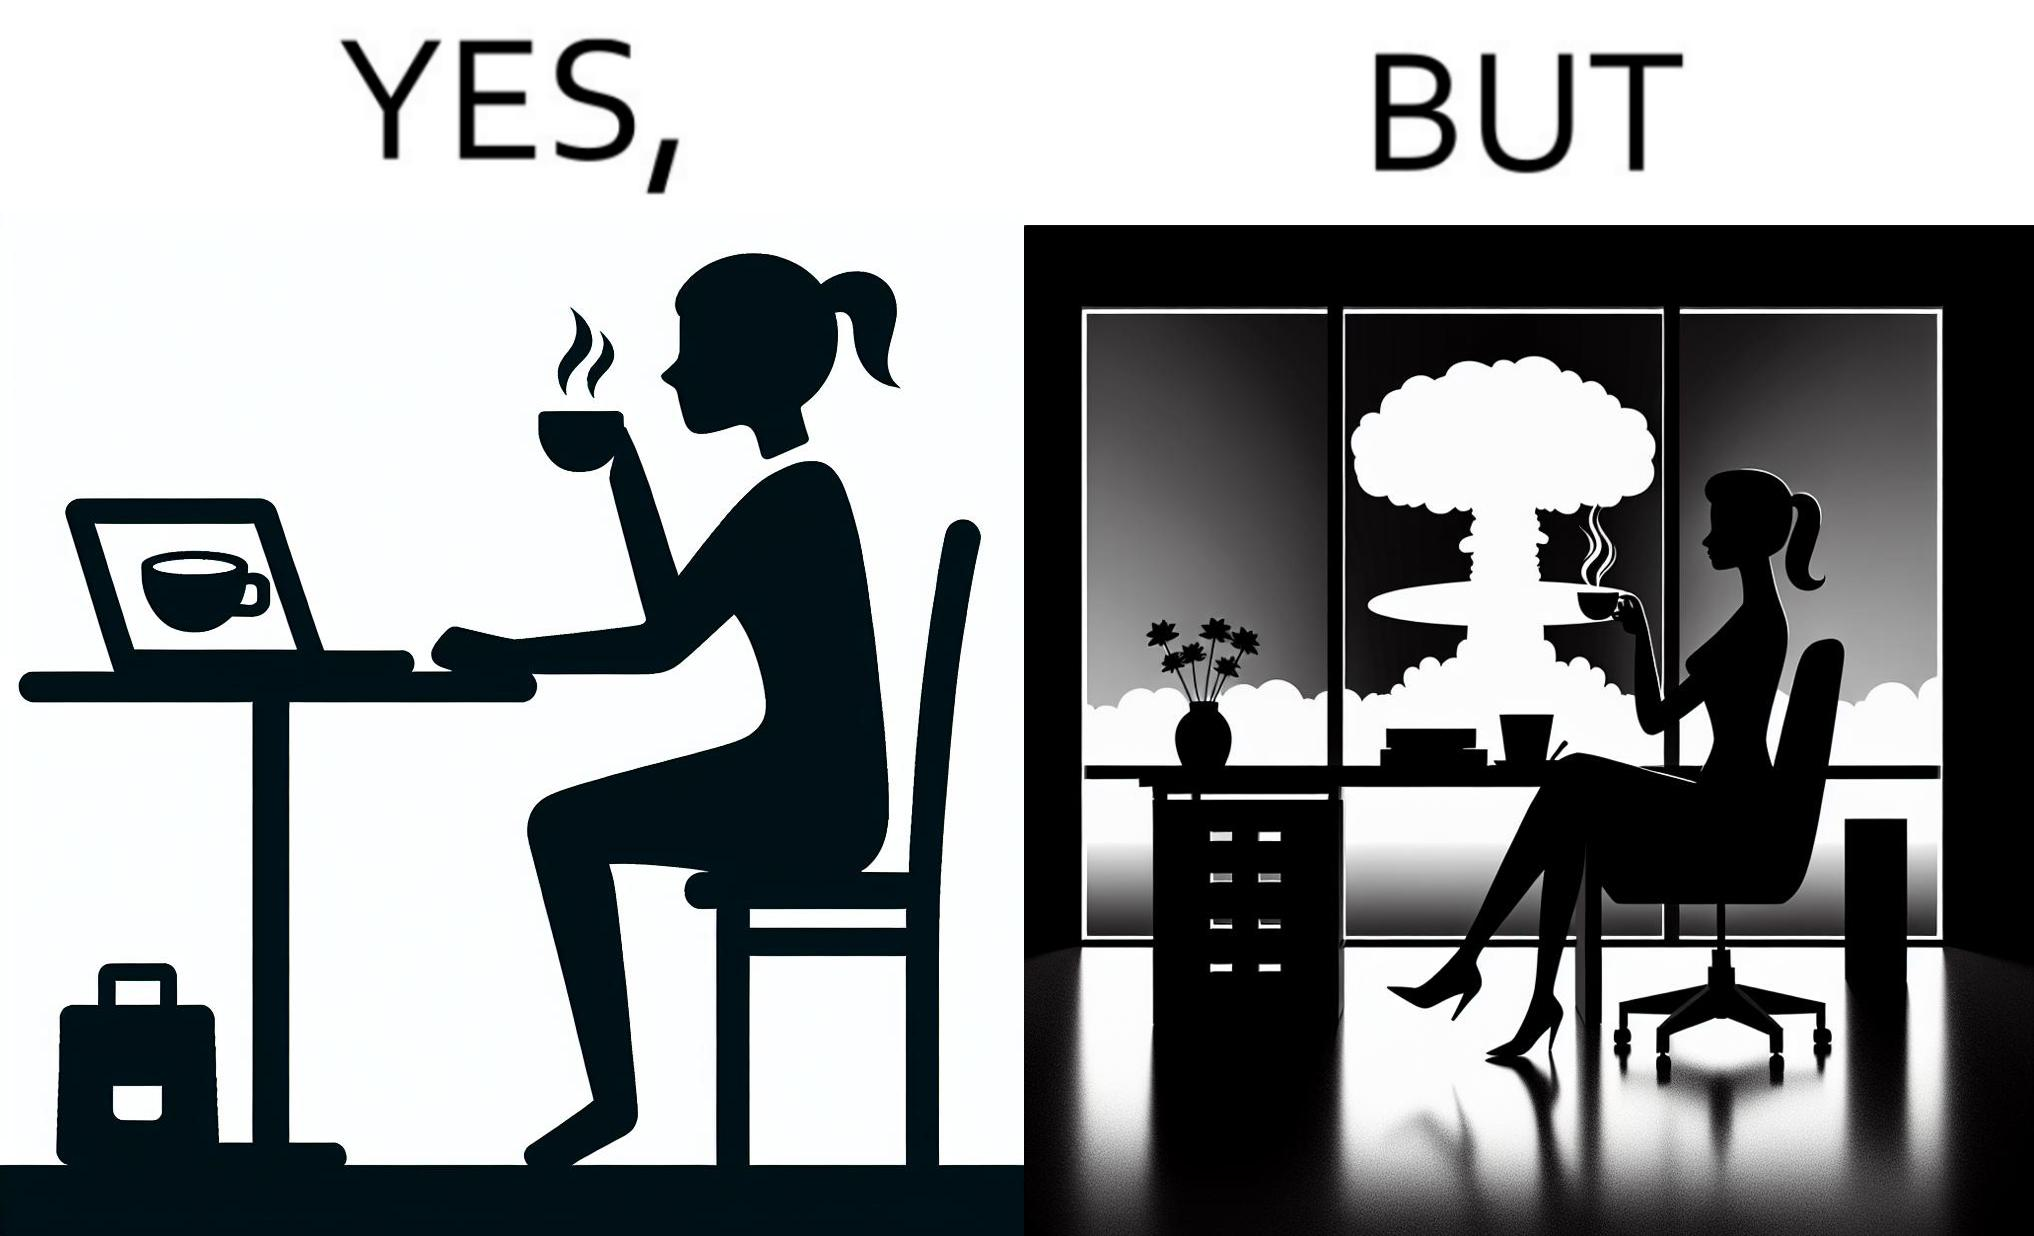Explain the humor or irony in this image. The images are funny since it shows a woman simply sipping from a cup at ease in a cafe with her laptop not caring about anything going on outside the cafe even though the situation is very grave,that is, a nuclear blast 